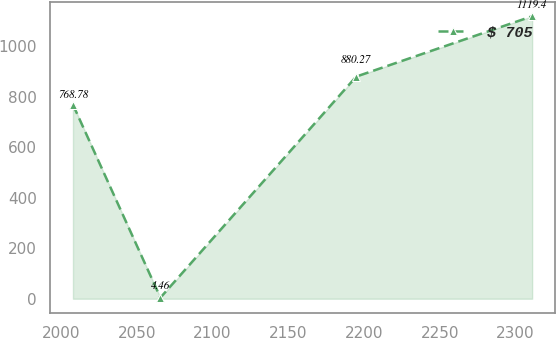Convert chart. <chart><loc_0><loc_0><loc_500><loc_500><line_chart><ecel><fcel>$ 705<nl><fcel>2007.74<fcel>768.78<nl><fcel>2065.52<fcel>4.46<nl><fcel>2194.89<fcel>880.27<nl><fcel>2311.13<fcel>1119.4<nl></chart> 